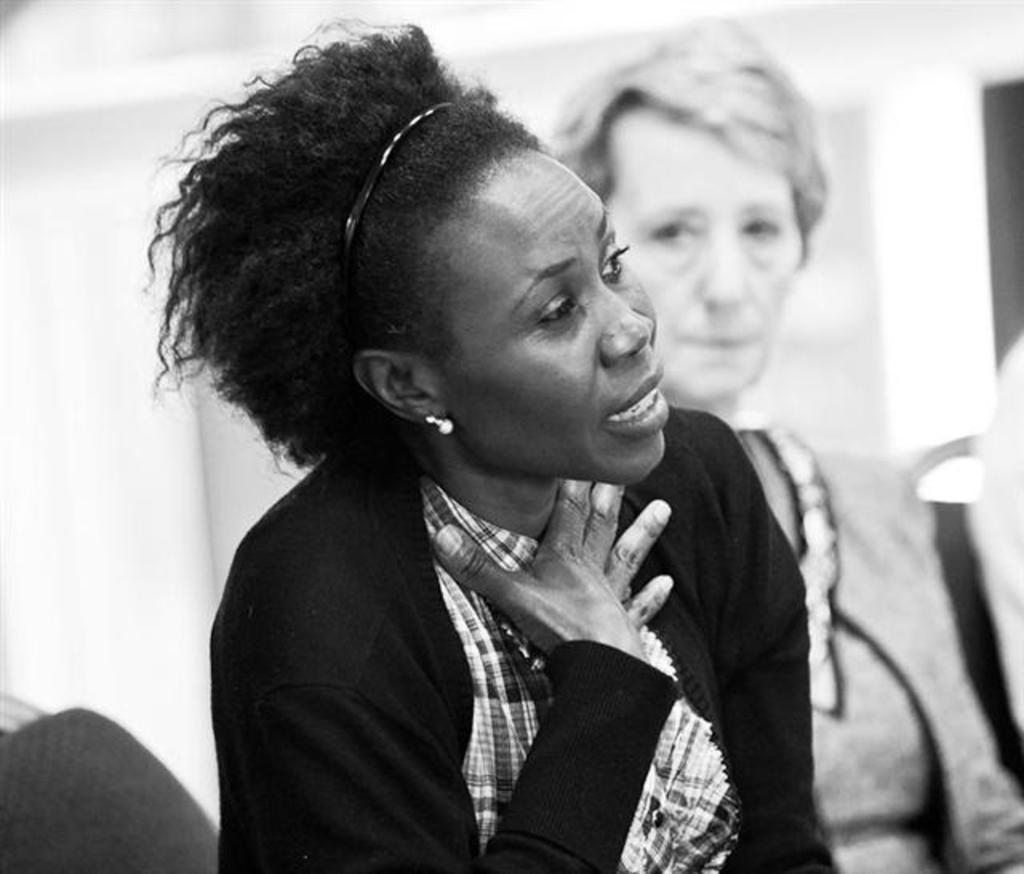How would you summarize this image in a sentence or two? In this picture I can see there is a woman sitting here and she is speaking wearing a hair band and she is looking at right side. There is another person on to right and there is a wall in the backdrop. 